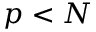<formula> <loc_0><loc_0><loc_500><loc_500>p < N</formula> 